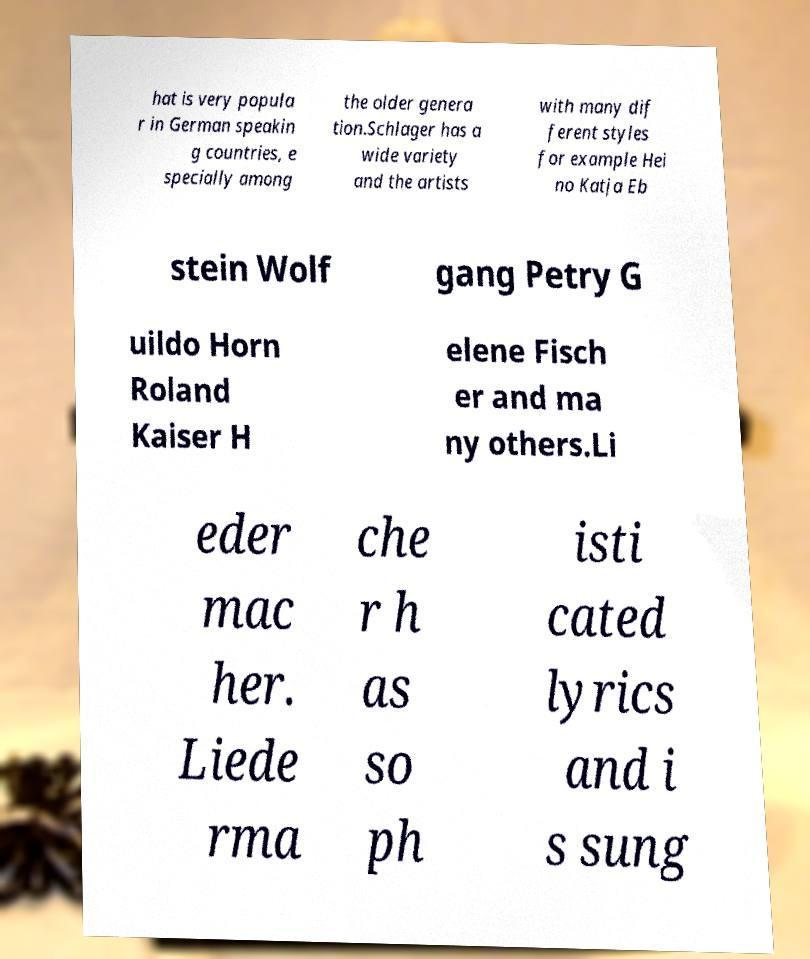What messages or text are displayed in this image? I need them in a readable, typed format. hat is very popula r in German speakin g countries, e specially among the older genera tion.Schlager has a wide variety and the artists with many dif ferent styles for example Hei no Katja Eb stein Wolf gang Petry G uildo Horn Roland Kaiser H elene Fisch er and ma ny others.Li eder mac her. Liede rma che r h as so ph isti cated lyrics and i s sung 